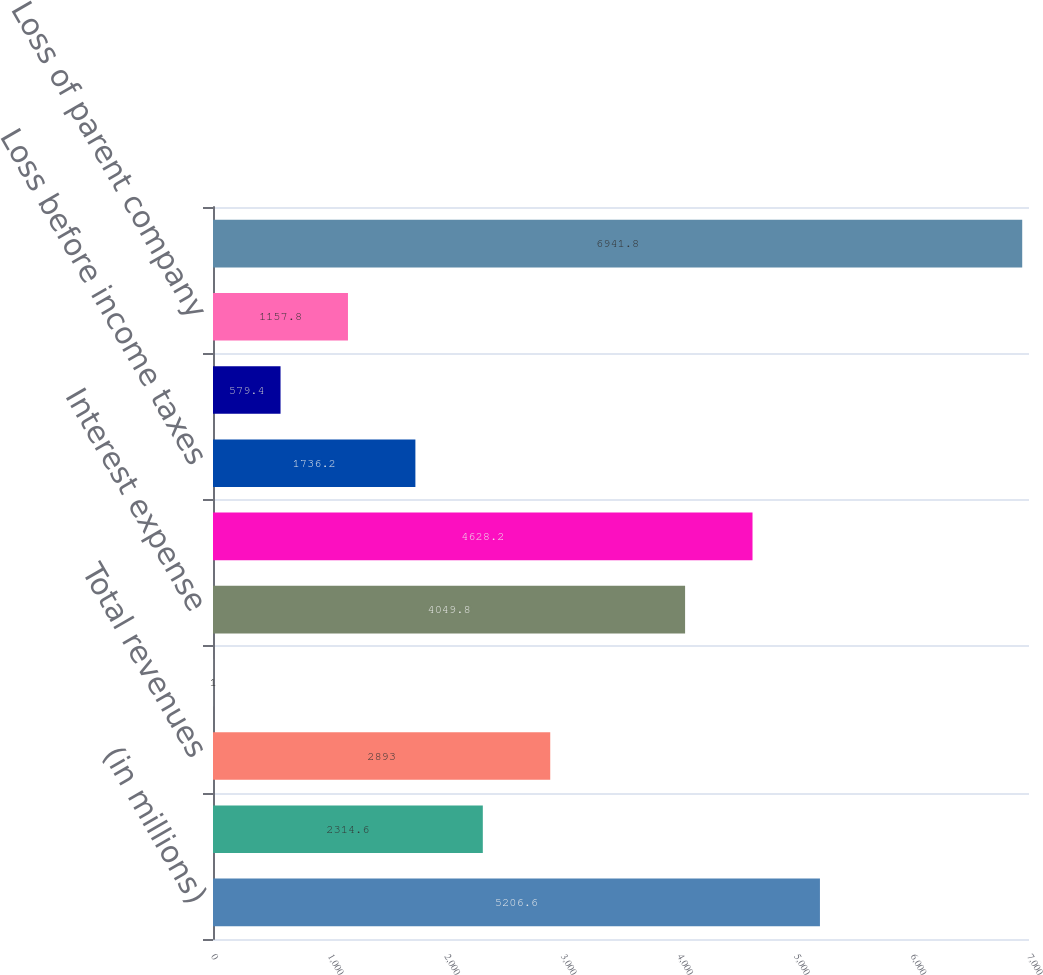Convert chart to OTSL. <chart><loc_0><loc_0><loc_500><loc_500><bar_chart><fcel>(in millions)<fcel>Investment and other income<fcel>Total revenues<fcel>Operating costs<fcel>Interest expense<fcel>Total operating costs<fcel>Loss before income taxes<fcel>Benefit for income taxes<fcel>Loss of parent company<fcel>Equity in undistributed income<nl><fcel>5206.6<fcel>2314.6<fcel>2893<fcel>1<fcel>4049.8<fcel>4628.2<fcel>1736.2<fcel>579.4<fcel>1157.8<fcel>6941.8<nl></chart> 